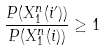<formula> <loc_0><loc_0><loc_500><loc_500>\frac { P ( X _ { 1 } ^ { n } ( i ^ { \prime } ) ) } { P ( X _ { 1 } ^ { n } ( i ) ) } \geq 1</formula> 